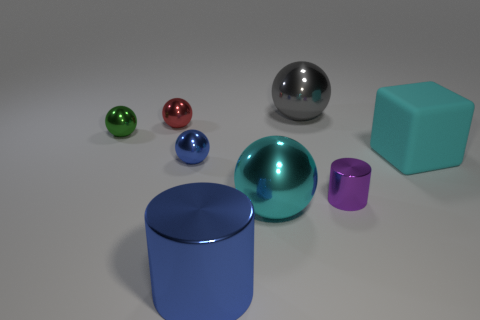Subtract all cubes. How many objects are left? 7 Subtract all tiny gray rubber blocks. Subtract all purple objects. How many objects are left? 7 Add 2 small metallic cylinders. How many small metallic cylinders are left? 3 Add 5 red rubber objects. How many red rubber objects exist? 5 Add 2 small cylinders. How many objects exist? 10 Subtract all cyan balls. How many balls are left? 4 Subtract all cyan metallic spheres. How many spheres are left? 4 Subtract 0 red blocks. How many objects are left? 8 Subtract all blue cylinders. Subtract all red blocks. How many cylinders are left? 1 Subtract all yellow balls. How many blue cylinders are left? 1 